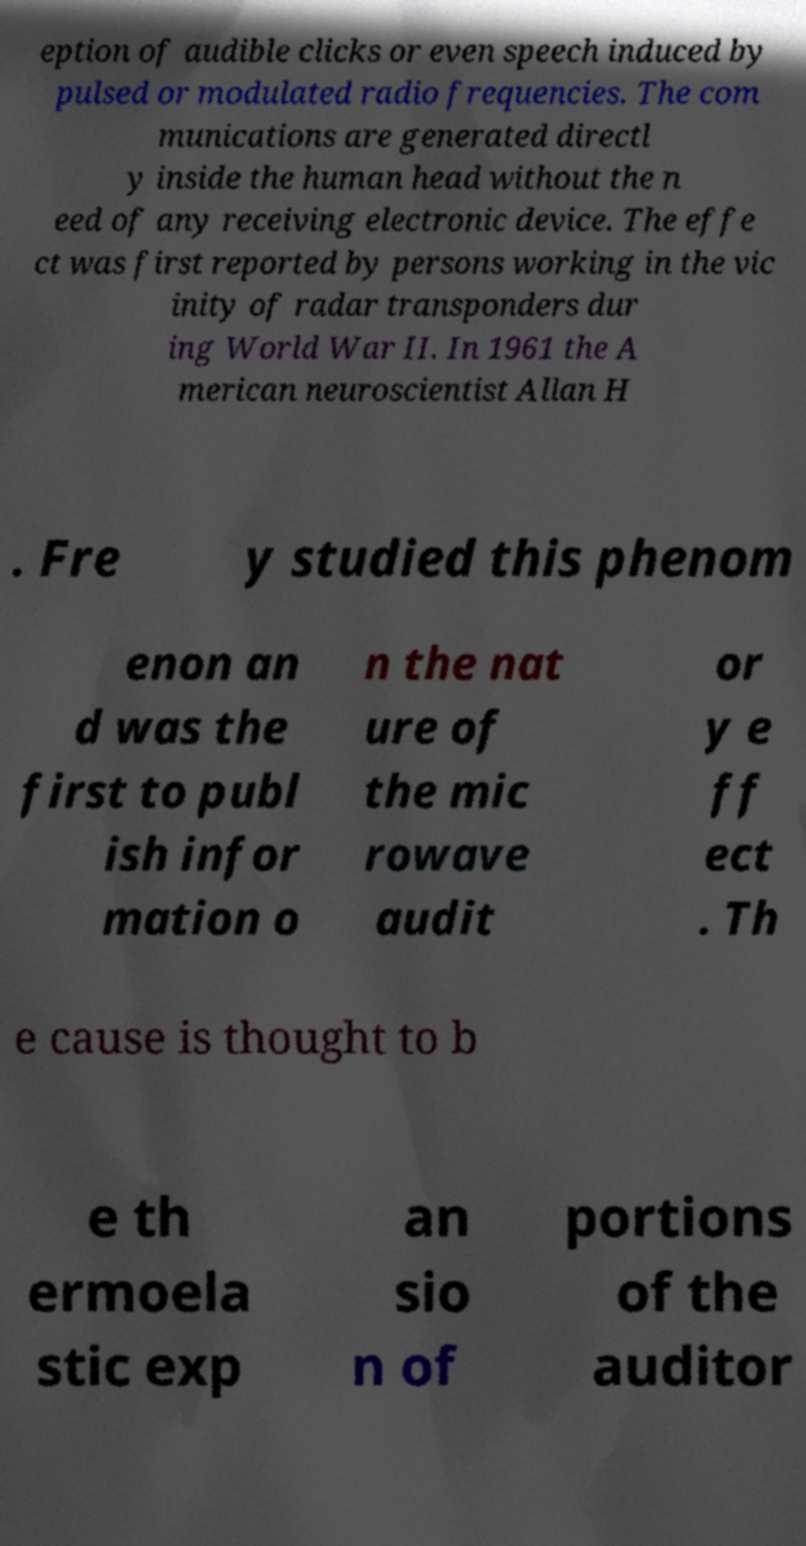I need the written content from this picture converted into text. Can you do that? eption of audible clicks or even speech induced by pulsed or modulated radio frequencies. The com munications are generated directl y inside the human head without the n eed of any receiving electronic device. The effe ct was first reported by persons working in the vic inity of radar transponders dur ing World War II. In 1961 the A merican neuroscientist Allan H . Fre y studied this phenom enon an d was the first to publ ish infor mation o n the nat ure of the mic rowave audit or y e ff ect . Th e cause is thought to b e th ermoela stic exp an sio n of portions of the auditor 